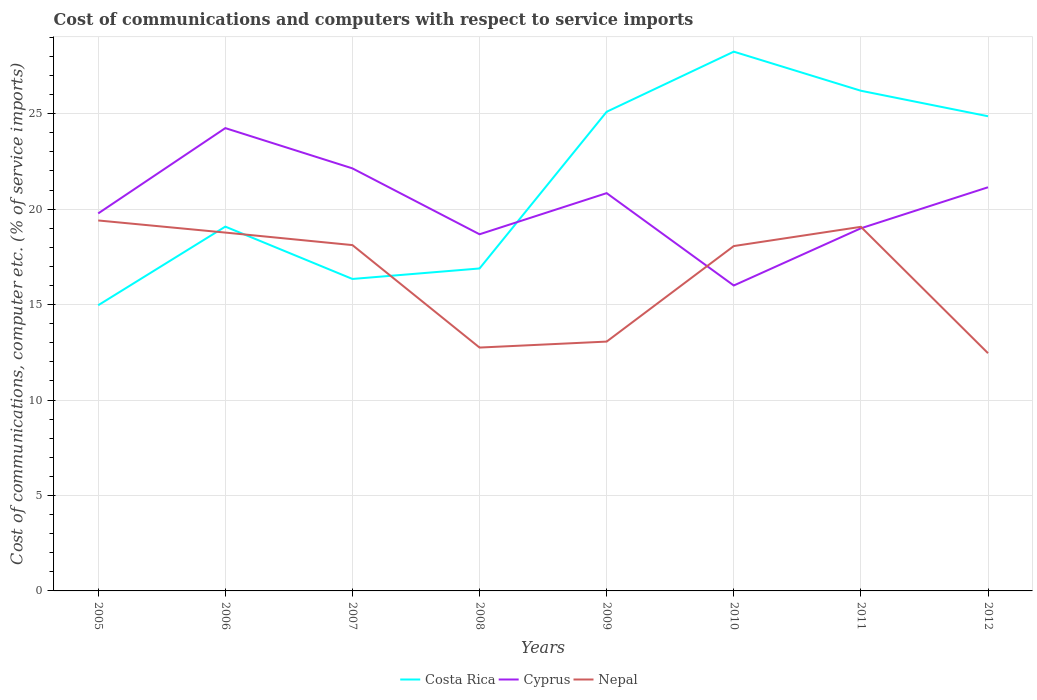Across all years, what is the maximum cost of communications and computers in Cyprus?
Offer a terse response. 16. In which year was the cost of communications and computers in Nepal maximum?
Make the answer very short. 2012. What is the total cost of communications and computers in Costa Rica in the graph?
Offer a terse response. 2.05. What is the difference between the highest and the second highest cost of communications and computers in Nepal?
Ensure brevity in your answer.  6.95. What is the difference between the highest and the lowest cost of communications and computers in Cyprus?
Your answer should be very brief. 4. Is the cost of communications and computers in Costa Rica strictly greater than the cost of communications and computers in Cyprus over the years?
Give a very brief answer. No. Are the values on the major ticks of Y-axis written in scientific E-notation?
Provide a short and direct response. No. Does the graph contain any zero values?
Your answer should be compact. No. Does the graph contain grids?
Make the answer very short. Yes. Where does the legend appear in the graph?
Offer a terse response. Bottom center. How many legend labels are there?
Keep it short and to the point. 3. How are the legend labels stacked?
Offer a very short reply. Horizontal. What is the title of the graph?
Offer a terse response. Cost of communications and computers with respect to service imports. What is the label or title of the Y-axis?
Provide a succinct answer. Cost of communications, computer etc. (% of service imports). What is the Cost of communications, computer etc. (% of service imports) of Costa Rica in 2005?
Give a very brief answer. 14.97. What is the Cost of communications, computer etc. (% of service imports) in Cyprus in 2005?
Your answer should be very brief. 19.78. What is the Cost of communications, computer etc. (% of service imports) in Nepal in 2005?
Provide a short and direct response. 19.41. What is the Cost of communications, computer etc. (% of service imports) of Costa Rica in 2006?
Your answer should be very brief. 19.09. What is the Cost of communications, computer etc. (% of service imports) in Cyprus in 2006?
Ensure brevity in your answer.  24.25. What is the Cost of communications, computer etc. (% of service imports) in Nepal in 2006?
Provide a short and direct response. 18.77. What is the Cost of communications, computer etc. (% of service imports) of Costa Rica in 2007?
Provide a short and direct response. 16.34. What is the Cost of communications, computer etc. (% of service imports) in Cyprus in 2007?
Your answer should be compact. 22.14. What is the Cost of communications, computer etc. (% of service imports) of Nepal in 2007?
Your response must be concise. 18.12. What is the Cost of communications, computer etc. (% of service imports) in Costa Rica in 2008?
Make the answer very short. 16.89. What is the Cost of communications, computer etc. (% of service imports) of Cyprus in 2008?
Offer a very short reply. 18.68. What is the Cost of communications, computer etc. (% of service imports) of Nepal in 2008?
Provide a short and direct response. 12.75. What is the Cost of communications, computer etc. (% of service imports) of Costa Rica in 2009?
Offer a terse response. 25.1. What is the Cost of communications, computer etc. (% of service imports) in Cyprus in 2009?
Provide a short and direct response. 20.84. What is the Cost of communications, computer etc. (% of service imports) of Nepal in 2009?
Provide a short and direct response. 13.06. What is the Cost of communications, computer etc. (% of service imports) in Costa Rica in 2010?
Offer a terse response. 28.25. What is the Cost of communications, computer etc. (% of service imports) in Cyprus in 2010?
Make the answer very short. 16. What is the Cost of communications, computer etc. (% of service imports) in Nepal in 2010?
Offer a very short reply. 18.07. What is the Cost of communications, computer etc. (% of service imports) of Costa Rica in 2011?
Keep it short and to the point. 26.2. What is the Cost of communications, computer etc. (% of service imports) of Cyprus in 2011?
Give a very brief answer. 19. What is the Cost of communications, computer etc. (% of service imports) of Nepal in 2011?
Your response must be concise. 19.07. What is the Cost of communications, computer etc. (% of service imports) of Costa Rica in 2012?
Your answer should be very brief. 24.87. What is the Cost of communications, computer etc. (% of service imports) of Cyprus in 2012?
Make the answer very short. 21.15. What is the Cost of communications, computer etc. (% of service imports) in Nepal in 2012?
Your answer should be very brief. 12.45. Across all years, what is the maximum Cost of communications, computer etc. (% of service imports) in Costa Rica?
Your response must be concise. 28.25. Across all years, what is the maximum Cost of communications, computer etc. (% of service imports) in Cyprus?
Provide a short and direct response. 24.25. Across all years, what is the maximum Cost of communications, computer etc. (% of service imports) in Nepal?
Keep it short and to the point. 19.41. Across all years, what is the minimum Cost of communications, computer etc. (% of service imports) of Costa Rica?
Keep it short and to the point. 14.97. Across all years, what is the minimum Cost of communications, computer etc. (% of service imports) in Cyprus?
Offer a very short reply. 16. Across all years, what is the minimum Cost of communications, computer etc. (% of service imports) in Nepal?
Ensure brevity in your answer.  12.45. What is the total Cost of communications, computer etc. (% of service imports) in Costa Rica in the graph?
Offer a very short reply. 171.71. What is the total Cost of communications, computer etc. (% of service imports) of Cyprus in the graph?
Give a very brief answer. 161.83. What is the total Cost of communications, computer etc. (% of service imports) of Nepal in the graph?
Provide a short and direct response. 131.7. What is the difference between the Cost of communications, computer etc. (% of service imports) in Costa Rica in 2005 and that in 2006?
Provide a short and direct response. -4.12. What is the difference between the Cost of communications, computer etc. (% of service imports) of Cyprus in 2005 and that in 2006?
Your answer should be compact. -4.47. What is the difference between the Cost of communications, computer etc. (% of service imports) in Nepal in 2005 and that in 2006?
Provide a succinct answer. 0.63. What is the difference between the Cost of communications, computer etc. (% of service imports) of Costa Rica in 2005 and that in 2007?
Provide a succinct answer. -1.38. What is the difference between the Cost of communications, computer etc. (% of service imports) of Cyprus in 2005 and that in 2007?
Offer a terse response. -2.36. What is the difference between the Cost of communications, computer etc. (% of service imports) in Nepal in 2005 and that in 2007?
Provide a short and direct response. 1.29. What is the difference between the Cost of communications, computer etc. (% of service imports) of Costa Rica in 2005 and that in 2008?
Provide a succinct answer. -1.93. What is the difference between the Cost of communications, computer etc. (% of service imports) of Cyprus in 2005 and that in 2008?
Provide a short and direct response. 1.09. What is the difference between the Cost of communications, computer etc. (% of service imports) of Nepal in 2005 and that in 2008?
Your answer should be compact. 6.66. What is the difference between the Cost of communications, computer etc. (% of service imports) of Costa Rica in 2005 and that in 2009?
Offer a terse response. -10.14. What is the difference between the Cost of communications, computer etc. (% of service imports) in Cyprus in 2005 and that in 2009?
Provide a short and direct response. -1.06. What is the difference between the Cost of communications, computer etc. (% of service imports) of Nepal in 2005 and that in 2009?
Make the answer very short. 6.35. What is the difference between the Cost of communications, computer etc. (% of service imports) of Costa Rica in 2005 and that in 2010?
Make the answer very short. -13.29. What is the difference between the Cost of communications, computer etc. (% of service imports) in Cyprus in 2005 and that in 2010?
Give a very brief answer. 3.78. What is the difference between the Cost of communications, computer etc. (% of service imports) of Nepal in 2005 and that in 2010?
Provide a succinct answer. 1.34. What is the difference between the Cost of communications, computer etc. (% of service imports) in Costa Rica in 2005 and that in 2011?
Offer a terse response. -11.24. What is the difference between the Cost of communications, computer etc. (% of service imports) in Cyprus in 2005 and that in 2011?
Offer a very short reply. 0.78. What is the difference between the Cost of communications, computer etc. (% of service imports) of Nepal in 2005 and that in 2011?
Your answer should be very brief. 0.33. What is the difference between the Cost of communications, computer etc. (% of service imports) in Costa Rica in 2005 and that in 2012?
Your answer should be very brief. -9.9. What is the difference between the Cost of communications, computer etc. (% of service imports) of Cyprus in 2005 and that in 2012?
Ensure brevity in your answer.  -1.37. What is the difference between the Cost of communications, computer etc. (% of service imports) in Nepal in 2005 and that in 2012?
Offer a terse response. 6.95. What is the difference between the Cost of communications, computer etc. (% of service imports) of Costa Rica in 2006 and that in 2007?
Your response must be concise. 2.74. What is the difference between the Cost of communications, computer etc. (% of service imports) of Cyprus in 2006 and that in 2007?
Keep it short and to the point. 2.11. What is the difference between the Cost of communications, computer etc. (% of service imports) in Nepal in 2006 and that in 2007?
Offer a terse response. 0.66. What is the difference between the Cost of communications, computer etc. (% of service imports) of Costa Rica in 2006 and that in 2008?
Make the answer very short. 2.19. What is the difference between the Cost of communications, computer etc. (% of service imports) of Cyprus in 2006 and that in 2008?
Provide a succinct answer. 5.56. What is the difference between the Cost of communications, computer etc. (% of service imports) of Nepal in 2006 and that in 2008?
Ensure brevity in your answer.  6.02. What is the difference between the Cost of communications, computer etc. (% of service imports) in Costa Rica in 2006 and that in 2009?
Offer a very short reply. -6.02. What is the difference between the Cost of communications, computer etc. (% of service imports) of Cyprus in 2006 and that in 2009?
Keep it short and to the point. 3.41. What is the difference between the Cost of communications, computer etc. (% of service imports) in Nepal in 2006 and that in 2009?
Ensure brevity in your answer.  5.71. What is the difference between the Cost of communications, computer etc. (% of service imports) in Costa Rica in 2006 and that in 2010?
Your answer should be very brief. -9.17. What is the difference between the Cost of communications, computer etc. (% of service imports) of Cyprus in 2006 and that in 2010?
Provide a short and direct response. 8.24. What is the difference between the Cost of communications, computer etc. (% of service imports) of Nepal in 2006 and that in 2010?
Your answer should be compact. 0.71. What is the difference between the Cost of communications, computer etc. (% of service imports) of Costa Rica in 2006 and that in 2011?
Provide a succinct answer. -7.12. What is the difference between the Cost of communications, computer etc. (% of service imports) in Cyprus in 2006 and that in 2011?
Make the answer very short. 5.25. What is the difference between the Cost of communications, computer etc. (% of service imports) of Nepal in 2006 and that in 2011?
Ensure brevity in your answer.  -0.3. What is the difference between the Cost of communications, computer etc. (% of service imports) in Costa Rica in 2006 and that in 2012?
Your response must be concise. -5.78. What is the difference between the Cost of communications, computer etc. (% of service imports) of Cyprus in 2006 and that in 2012?
Provide a succinct answer. 3.1. What is the difference between the Cost of communications, computer etc. (% of service imports) in Nepal in 2006 and that in 2012?
Offer a very short reply. 6.32. What is the difference between the Cost of communications, computer etc. (% of service imports) in Costa Rica in 2007 and that in 2008?
Your answer should be compact. -0.55. What is the difference between the Cost of communications, computer etc. (% of service imports) in Cyprus in 2007 and that in 2008?
Ensure brevity in your answer.  3.45. What is the difference between the Cost of communications, computer etc. (% of service imports) in Nepal in 2007 and that in 2008?
Provide a succinct answer. 5.37. What is the difference between the Cost of communications, computer etc. (% of service imports) of Costa Rica in 2007 and that in 2009?
Offer a terse response. -8.76. What is the difference between the Cost of communications, computer etc. (% of service imports) in Cyprus in 2007 and that in 2009?
Provide a short and direct response. 1.3. What is the difference between the Cost of communications, computer etc. (% of service imports) in Nepal in 2007 and that in 2009?
Ensure brevity in your answer.  5.05. What is the difference between the Cost of communications, computer etc. (% of service imports) of Costa Rica in 2007 and that in 2010?
Offer a very short reply. -11.91. What is the difference between the Cost of communications, computer etc. (% of service imports) in Cyprus in 2007 and that in 2010?
Your answer should be very brief. 6.14. What is the difference between the Cost of communications, computer etc. (% of service imports) in Nepal in 2007 and that in 2010?
Offer a very short reply. 0.05. What is the difference between the Cost of communications, computer etc. (% of service imports) of Costa Rica in 2007 and that in 2011?
Your answer should be compact. -9.86. What is the difference between the Cost of communications, computer etc. (% of service imports) in Cyprus in 2007 and that in 2011?
Offer a terse response. 3.14. What is the difference between the Cost of communications, computer etc. (% of service imports) of Nepal in 2007 and that in 2011?
Make the answer very short. -0.96. What is the difference between the Cost of communications, computer etc. (% of service imports) in Costa Rica in 2007 and that in 2012?
Your answer should be compact. -8.52. What is the difference between the Cost of communications, computer etc. (% of service imports) of Nepal in 2007 and that in 2012?
Provide a succinct answer. 5.66. What is the difference between the Cost of communications, computer etc. (% of service imports) of Costa Rica in 2008 and that in 2009?
Give a very brief answer. -8.21. What is the difference between the Cost of communications, computer etc. (% of service imports) in Cyprus in 2008 and that in 2009?
Your answer should be compact. -2.16. What is the difference between the Cost of communications, computer etc. (% of service imports) in Nepal in 2008 and that in 2009?
Your response must be concise. -0.31. What is the difference between the Cost of communications, computer etc. (% of service imports) of Costa Rica in 2008 and that in 2010?
Provide a succinct answer. -11.36. What is the difference between the Cost of communications, computer etc. (% of service imports) of Cyprus in 2008 and that in 2010?
Give a very brief answer. 2.68. What is the difference between the Cost of communications, computer etc. (% of service imports) in Nepal in 2008 and that in 2010?
Keep it short and to the point. -5.32. What is the difference between the Cost of communications, computer etc. (% of service imports) in Costa Rica in 2008 and that in 2011?
Ensure brevity in your answer.  -9.31. What is the difference between the Cost of communications, computer etc. (% of service imports) of Cyprus in 2008 and that in 2011?
Your answer should be compact. -0.31. What is the difference between the Cost of communications, computer etc. (% of service imports) in Nepal in 2008 and that in 2011?
Provide a succinct answer. -6.33. What is the difference between the Cost of communications, computer etc. (% of service imports) of Costa Rica in 2008 and that in 2012?
Make the answer very short. -7.97. What is the difference between the Cost of communications, computer etc. (% of service imports) in Cyprus in 2008 and that in 2012?
Your response must be concise. -2.46. What is the difference between the Cost of communications, computer etc. (% of service imports) of Nepal in 2008 and that in 2012?
Your answer should be very brief. 0.3. What is the difference between the Cost of communications, computer etc. (% of service imports) of Costa Rica in 2009 and that in 2010?
Keep it short and to the point. -3.15. What is the difference between the Cost of communications, computer etc. (% of service imports) of Cyprus in 2009 and that in 2010?
Make the answer very short. 4.84. What is the difference between the Cost of communications, computer etc. (% of service imports) of Nepal in 2009 and that in 2010?
Offer a very short reply. -5. What is the difference between the Cost of communications, computer etc. (% of service imports) in Costa Rica in 2009 and that in 2011?
Offer a terse response. -1.1. What is the difference between the Cost of communications, computer etc. (% of service imports) of Cyprus in 2009 and that in 2011?
Your answer should be very brief. 1.84. What is the difference between the Cost of communications, computer etc. (% of service imports) in Nepal in 2009 and that in 2011?
Your answer should be very brief. -6.01. What is the difference between the Cost of communications, computer etc. (% of service imports) in Costa Rica in 2009 and that in 2012?
Keep it short and to the point. 0.23. What is the difference between the Cost of communications, computer etc. (% of service imports) of Cyprus in 2009 and that in 2012?
Offer a terse response. -0.31. What is the difference between the Cost of communications, computer etc. (% of service imports) in Nepal in 2009 and that in 2012?
Make the answer very short. 0.61. What is the difference between the Cost of communications, computer etc. (% of service imports) in Costa Rica in 2010 and that in 2011?
Your answer should be compact. 2.05. What is the difference between the Cost of communications, computer etc. (% of service imports) of Cyprus in 2010 and that in 2011?
Make the answer very short. -3. What is the difference between the Cost of communications, computer etc. (% of service imports) of Nepal in 2010 and that in 2011?
Your response must be concise. -1.01. What is the difference between the Cost of communications, computer etc. (% of service imports) of Costa Rica in 2010 and that in 2012?
Make the answer very short. 3.38. What is the difference between the Cost of communications, computer etc. (% of service imports) in Cyprus in 2010 and that in 2012?
Give a very brief answer. -5.15. What is the difference between the Cost of communications, computer etc. (% of service imports) of Nepal in 2010 and that in 2012?
Provide a succinct answer. 5.61. What is the difference between the Cost of communications, computer etc. (% of service imports) of Costa Rica in 2011 and that in 2012?
Keep it short and to the point. 1.34. What is the difference between the Cost of communications, computer etc. (% of service imports) in Cyprus in 2011 and that in 2012?
Ensure brevity in your answer.  -2.15. What is the difference between the Cost of communications, computer etc. (% of service imports) of Nepal in 2011 and that in 2012?
Ensure brevity in your answer.  6.62. What is the difference between the Cost of communications, computer etc. (% of service imports) of Costa Rica in 2005 and the Cost of communications, computer etc. (% of service imports) of Cyprus in 2006?
Provide a short and direct response. -9.28. What is the difference between the Cost of communications, computer etc. (% of service imports) in Costa Rica in 2005 and the Cost of communications, computer etc. (% of service imports) in Nepal in 2006?
Make the answer very short. -3.81. What is the difference between the Cost of communications, computer etc. (% of service imports) of Cyprus in 2005 and the Cost of communications, computer etc. (% of service imports) of Nepal in 2006?
Offer a very short reply. 1. What is the difference between the Cost of communications, computer etc. (% of service imports) of Costa Rica in 2005 and the Cost of communications, computer etc. (% of service imports) of Cyprus in 2007?
Give a very brief answer. -7.17. What is the difference between the Cost of communications, computer etc. (% of service imports) in Costa Rica in 2005 and the Cost of communications, computer etc. (% of service imports) in Nepal in 2007?
Give a very brief answer. -3.15. What is the difference between the Cost of communications, computer etc. (% of service imports) in Cyprus in 2005 and the Cost of communications, computer etc. (% of service imports) in Nepal in 2007?
Keep it short and to the point. 1.66. What is the difference between the Cost of communications, computer etc. (% of service imports) of Costa Rica in 2005 and the Cost of communications, computer etc. (% of service imports) of Cyprus in 2008?
Your answer should be very brief. -3.72. What is the difference between the Cost of communications, computer etc. (% of service imports) in Costa Rica in 2005 and the Cost of communications, computer etc. (% of service imports) in Nepal in 2008?
Your response must be concise. 2.22. What is the difference between the Cost of communications, computer etc. (% of service imports) of Cyprus in 2005 and the Cost of communications, computer etc. (% of service imports) of Nepal in 2008?
Your answer should be compact. 7.03. What is the difference between the Cost of communications, computer etc. (% of service imports) of Costa Rica in 2005 and the Cost of communications, computer etc. (% of service imports) of Cyprus in 2009?
Your answer should be very brief. -5.87. What is the difference between the Cost of communications, computer etc. (% of service imports) in Costa Rica in 2005 and the Cost of communications, computer etc. (% of service imports) in Nepal in 2009?
Provide a short and direct response. 1.9. What is the difference between the Cost of communications, computer etc. (% of service imports) in Cyprus in 2005 and the Cost of communications, computer etc. (% of service imports) in Nepal in 2009?
Offer a very short reply. 6.71. What is the difference between the Cost of communications, computer etc. (% of service imports) of Costa Rica in 2005 and the Cost of communications, computer etc. (% of service imports) of Cyprus in 2010?
Provide a succinct answer. -1.03. What is the difference between the Cost of communications, computer etc. (% of service imports) of Costa Rica in 2005 and the Cost of communications, computer etc. (% of service imports) of Nepal in 2010?
Offer a terse response. -3.1. What is the difference between the Cost of communications, computer etc. (% of service imports) of Cyprus in 2005 and the Cost of communications, computer etc. (% of service imports) of Nepal in 2010?
Provide a succinct answer. 1.71. What is the difference between the Cost of communications, computer etc. (% of service imports) in Costa Rica in 2005 and the Cost of communications, computer etc. (% of service imports) in Cyprus in 2011?
Offer a very short reply. -4.03. What is the difference between the Cost of communications, computer etc. (% of service imports) in Costa Rica in 2005 and the Cost of communications, computer etc. (% of service imports) in Nepal in 2011?
Provide a short and direct response. -4.11. What is the difference between the Cost of communications, computer etc. (% of service imports) of Cyprus in 2005 and the Cost of communications, computer etc. (% of service imports) of Nepal in 2011?
Provide a succinct answer. 0.7. What is the difference between the Cost of communications, computer etc. (% of service imports) in Costa Rica in 2005 and the Cost of communications, computer etc. (% of service imports) in Cyprus in 2012?
Offer a very short reply. -6.18. What is the difference between the Cost of communications, computer etc. (% of service imports) in Costa Rica in 2005 and the Cost of communications, computer etc. (% of service imports) in Nepal in 2012?
Ensure brevity in your answer.  2.51. What is the difference between the Cost of communications, computer etc. (% of service imports) in Cyprus in 2005 and the Cost of communications, computer etc. (% of service imports) in Nepal in 2012?
Offer a terse response. 7.32. What is the difference between the Cost of communications, computer etc. (% of service imports) in Costa Rica in 2006 and the Cost of communications, computer etc. (% of service imports) in Cyprus in 2007?
Offer a very short reply. -3.05. What is the difference between the Cost of communications, computer etc. (% of service imports) in Cyprus in 2006 and the Cost of communications, computer etc. (% of service imports) in Nepal in 2007?
Ensure brevity in your answer.  6.13. What is the difference between the Cost of communications, computer etc. (% of service imports) of Costa Rica in 2006 and the Cost of communications, computer etc. (% of service imports) of Cyprus in 2008?
Your response must be concise. 0.4. What is the difference between the Cost of communications, computer etc. (% of service imports) in Costa Rica in 2006 and the Cost of communications, computer etc. (% of service imports) in Nepal in 2008?
Your response must be concise. 6.34. What is the difference between the Cost of communications, computer etc. (% of service imports) of Cyprus in 2006 and the Cost of communications, computer etc. (% of service imports) of Nepal in 2008?
Ensure brevity in your answer.  11.5. What is the difference between the Cost of communications, computer etc. (% of service imports) in Costa Rica in 2006 and the Cost of communications, computer etc. (% of service imports) in Cyprus in 2009?
Make the answer very short. -1.75. What is the difference between the Cost of communications, computer etc. (% of service imports) of Costa Rica in 2006 and the Cost of communications, computer etc. (% of service imports) of Nepal in 2009?
Your answer should be compact. 6.02. What is the difference between the Cost of communications, computer etc. (% of service imports) of Cyprus in 2006 and the Cost of communications, computer etc. (% of service imports) of Nepal in 2009?
Keep it short and to the point. 11.18. What is the difference between the Cost of communications, computer etc. (% of service imports) in Costa Rica in 2006 and the Cost of communications, computer etc. (% of service imports) in Cyprus in 2010?
Provide a succinct answer. 3.08. What is the difference between the Cost of communications, computer etc. (% of service imports) in Costa Rica in 2006 and the Cost of communications, computer etc. (% of service imports) in Nepal in 2010?
Your response must be concise. 1.02. What is the difference between the Cost of communications, computer etc. (% of service imports) in Cyprus in 2006 and the Cost of communications, computer etc. (% of service imports) in Nepal in 2010?
Give a very brief answer. 6.18. What is the difference between the Cost of communications, computer etc. (% of service imports) in Costa Rica in 2006 and the Cost of communications, computer etc. (% of service imports) in Cyprus in 2011?
Your response must be concise. 0.09. What is the difference between the Cost of communications, computer etc. (% of service imports) of Costa Rica in 2006 and the Cost of communications, computer etc. (% of service imports) of Nepal in 2011?
Give a very brief answer. 0.01. What is the difference between the Cost of communications, computer etc. (% of service imports) in Cyprus in 2006 and the Cost of communications, computer etc. (% of service imports) in Nepal in 2011?
Your answer should be very brief. 5.17. What is the difference between the Cost of communications, computer etc. (% of service imports) in Costa Rica in 2006 and the Cost of communications, computer etc. (% of service imports) in Cyprus in 2012?
Offer a very short reply. -2.06. What is the difference between the Cost of communications, computer etc. (% of service imports) in Costa Rica in 2006 and the Cost of communications, computer etc. (% of service imports) in Nepal in 2012?
Your response must be concise. 6.63. What is the difference between the Cost of communications, computer etc. (% of service imports) in Cyprus in 2006 and the Cost of communications, computer etc. (% of service imports) in Nepal in 2012?
Keep it short and to the point. 11.79. What is the difference between the Cost of communications, computer etc. (% of service imports) in Costa Rica in 2007 and the Cost of communications, computer etc. (% of service imports) in Cyprus in 2008?
Give a very brief answer. -2.34. What is the difference between the Cost of communications, computer etc. (% of service imports) in Costa Rica in 2007 and the Cost of communications, computer etc. (% of service imports) in Nepal in 2008?
Your answer should be very brief. 3.59. What is the difference between the Cost of communications, computer etc. (% of service imports) of Cyprus in 2007 and the Cost of communications, computer etc. (% of service imports) of Nepal in 2008?
Offer a terse response. 9.39. What is the difference between the Cost of communications, computer etc. (% of service imports) of Costa Rica in 2007 and the Cost of communications, computer etc. (% of service imports) of Cyprus in 2009?
Give a very brief answer. -4.5. What is the difference between the Cost of communications, computer etc. (% of service imports) in Costa Rica in 2007 and the Cost of communications, computer etc. (% of service imports) in Nepal in 2009?
Provide a short and direct response. 3.28. What is the difference between the Cost of communications, computer etc. (% of service imports) of Cyprus in 2007 and the Cost of communications, computer etc. (% of service imports) of Nepal in 2009?
Your answer should be very brief. 9.07. What is the difference between the Cost of communications, computer etc. (% of service imports) in Costa Rica in 2007 and the Cost of communications, computer etc. (% of service imports) in Cyprus in 2010?
Give a very brief answer. 0.34. What is the difference between the Cost of communications, computer etc. (% of service imports) in Costa Rica in 2007 and the Cost of communications, computer etc. (% of service imports) in Nepal in 2010?
Offer a terse response. -1.72. What is the difference between the Cost of communications, computer etc. (% of service imports) of Cyprus in 2007 and the Cost of communications, computer etc. (% of service imports) of Nepal in 2010?
Make the answer very short. 4.07. What is the difference between the Cost of communications, computer etc. (% of service imports) in Costa Rica in 2007 and the Cost of communications, computer etc. (% of service imports) in Cyprus in 2011?
Provide a succinct answer. -2.65. What is the difference between the Cost of communications, computer etc. (% of service imports) in Costa Rica in 2007 and the Cost of communications, computer etc. (% of service imports) in Nepal in 2011?
Provide a short and direct response. -2.73. What is the difference between the Cost of communications, computer etc. (% of service imports) in Cyprus in 2007 and the Cost of communications, computer etc. (% of service imports) in Nepal in 2011?
Your answer should be compact. 3.06. What is the difference between the Cost of communications, computer etc. (% of service imports) of Costa Rica in 2007 and the Cost of communications, computer etc. (% of service imports) of Cyprus in 2012?
Offer a very short reply. -4.8. What is the difference between the Cost of communications, computer etc. (% of service imports) of Costa Rica in 2007 and the Cost of communications, computer etc. (% of service imports) of Nepal in 2012?
Your answer should be compact. 3.89. What is the difference between the Cost of communications, computer etc. (% of service imports) of Cyprus in 2007 and the Cost of communications, computer etc. (% of service imports) of Nepal in 2012?
Provide a succinct answer. 9.68. What is the difference between the Cost of communications, computer etc. (% of service imports) of Costa Rica in 2008 and the Cost of communications, computer etc. (% of service imports) of Cyprus in 2009?
Provide a succinct answer. -3.95. What is the difference between the Cost of communications, computer etc. (% of service imports) of Costa Rica in 2008 and the Cost of communications, computer etc. (% of service imports) of Nepal in 2009?
Give a very brief answer. 3.83. What is the difference between the Cost of communications, computer etc. (% of service imports) of Cyprus in 2008 and the Cost of communications, computer etc. (% of service imports) of Nepal in 2009?
Give a very brief answer. 5.62. What is the difference between the Cost of communications, computer etc. (% of service imports) in Costa Rica in 2008 and the Cost of communications, computer etc. (% of service imports) in Cyprus in 2010?
Ensure brevity in your answer.  0.89. What is the difference between the Cost of communications, computer etc. (% of service imports) of Costa Rica in 2008 and the Cost of communications, computer etc. (% of service imports) of Nepal in 2010?
Provide a short and direct response. -1.17. What is the difference between the Cost of communications, computer etc. (% of service imports) of Cyprus in 2008 and the Cost of communications, computer etc. (% of service imports) of Nepal in 2010?
Give a very brief answer. 0.62. What is the difference between the Cost of communications, computer etc. (% of service imports) in Costa Rica in 2008 and the Cost of communications, computer etc. (% of service imports) in Cyprus in 2011?
Your answer should be very brief. -2.1. What is the difference between the Cost of communications, computer etc. (% of service imports) in Costa Rica in 2008 and the Cost of communications, computer etc. (% of service imports) in Nepal in 2011?
Provide a succinct answer. -2.18. What is the difference between the Cost of communications, computer etc. (% of service imports) of Cyprus in 2008 and the Cost of communications, computer etc. (% of service imports) of Nepal in 2011?
Ensure brevity in your answer.  -0.39. What is the difference between the Cost of communications, computer etc. (% of service imports) of Costa Rica in 2008 and the Cost of communications, computer etc. (% of service imports) of Cyprus in 2012?
Offer a terse response. -4.25. What is the difference between the Cost of communications, computer etc. (% of service imports) of Costa Rica in 2008 and the Cost of communications, computer etc. (% of service imports) of Nepal in 2012?
Your response must be concise. 4.44. What is the difference between the Cost of communications, computer etc. (% of service imports) in Cyprus in 2008 and the Cost of communications, computer etc. (% of service imports) in Nepal in 2012?
Make the answer very short. 6.23. What is the difference between the Cost of communications, computer etc. (% of service imports) of Costa Rica in 2009 and the Cost of communications, computer etc. (% of service imports) of Cyprus in 2010?
Provide a short and direct response. 9.1. What is the difference between the Cost of communications, computer etc. (% of service imports) in Costa Rica in 2009 and the Cost of communications, computer etc. (% of service imports) in Nepal in 2010?
Your answer should be compact. 7.04. What is the difference between the Cost of communications, computer etc. (% of service imports) in Cyprus in 2009 and the Cost of communications, computer etc. (% of service imports) in Nepal in 2010?
Offer a very short reply. 2.77. What is the difference between the Cost of communications, computer etc. (% of service imports) in Costa Rica in 2009 and the Cost of communications, computer etc. (% of service imports) in Cyprus in 2011?
Keep it short and to the point. 6.1. What is the difference between the Cost of communications, computer etc. (% of service imports) in Costa Rica in 2009 and the Cost of communications, computer etc. (% of service imports) in Nepal in 2011?
Make the answer very short. 6.03. What is the difference between the Cost of communications, computer etc. (% of service imports) in Cyprus in 2009 and the Cost of communications, computer etc. (% of service imports) in Nepal in 2011?
Give a very brief answer. 1.77. What is the difference between the Cost of communications, computer etc. (% of service imports) in Costa Rica in 2009 and the Cost of communications, computer etc. (% of service imports) in Cyprus in 2012?
Provide a short and direct response. 3.96. What is the difference between the Cost of communications, computer etc. (% of service imports) of Costa Rica in 2009 and the Cost of communications, computer etc. (% of service imports) of Nepal in 2012?
Your answer should be very brief. 12.65. What is the difference between the Cost of communications, computer etc. (% of service imports) in Cyprus in 2009 and the Cost of communications, computer etc. (% of service imports) in Nepal in 2012?
Offer a very short reply. 8.39. What is the difference between the Cost of communications, computer etc. (% of service imports) in Costa Rica in 2010 and the Cost of communications, computer etc. (% of service imports) in Cyprus in 2011?
Provide a short and direct response. 9.25. What is the difference between the Cost of communications, computer etc. (% of service imports) of Costa Rica in 2010 and the Cost of communications, computer etc. (% of service imports) of Nepal in 2011?
Offer a very short reply. 9.18. What is the difference between the Cost of communications, computer etc. (% of service imports) in Cyprus in 2010 and the Cost of communications, computer etc. (% of service imports) in Nepal in 2011?
Keep it short and to the point. -3.07. What is the difference between the Cost of communications, computer etc. (% of service imports) of Costa Rica in 2010 and the Cost of communications, computer etc. (% of service imports) of Cyprus in 2012?
Ensure brevity in your answer.  7.1. What is the difference between the Cost of communications, computer etc. (% of service imports) of Costa Rica in 2010 and the Cost of communications, computer etc. (% of service imports) of Nepal in 2012?
Make the answer very short. 15.8. What is the difference between the Cost of communications, computer etc. (% of service imports) of Cyprus in 2010 and the Cost of communications, computer etc. (% of service imports) of Nepal in 2012?
Offer a very short reply. 3.55. What is the difference between the Cost of communications, computer etc. (% of service imports) of Costa Rica in 2011 and the Cost of communications, computer etc. (% of service imports) of Cyprus in 2012?
Your answer should be compact. 5.06. What is the difference between the Cost of communications, computer etc. (% of service imports) in Costa Rica in 2011 and the Cost of communications, computer etc. (% of service imports) in Nepal in 2012?
Offer a very short reply. 13.75. What is the difference between the Cost of communications, computer etc. (% of service imports) of Cyprus in 2011 and the Cost of communications, computer etc. (% of service imports) of Nepal in 2012?
Provide a short and direct response. 6.54. What is the average Cost of communications, computer etc. (% of service imports) in Costa Rica per year?
Ensure brevity in your answer.  21.46. What is the average Cost of communications, computer etc. (% of service imports) of Cyprus per year?
Your answer should be very brief. 20.23. What is the average Cost of communications, computer etc. (% of service imports) of Nepal per year?
Keep it short and to the point. 16.46. In the year 2005, what is the difference between the Cost of communications, computer etc. (% of service imports) of Costa Rica and Cost of communications, computer etc. (% of service imports) of Cyprus?
Make the answer very short. -4.81. In the year 2005, what is the difference between the Cost of communications, computer etc. (% of service imports) of Costa Rica and Cost of communications, computer etc. (% of service imports) of Nepal?
Provide a short and direct response. -4.44. In the year 2005, what is the difference between the Cost of communications, computer etc. (% of service imports) in Cyprus and Cost of communications, computer etc. (% of service imports) in Nepal?
Provide a succinct answer. 0.37. In the year 2006, what is the difference between the Cost of communications, computer etc. (% of service imports) in Costa Rica and Cost of communications, computer etc. (% of service imports) in Cyprus?
Your answer should be compact. -5.16. In the year 2006, what is the difference between the Cost of communications, computer etc. (% of service imports) of Costa Rica and Cost of communications, computer etc. (% of service imports) of Nepal?
Your answer should be very brief. 0.31. In the year 2006, what is the difference between the Cost of communications, computer etc. (% of service imports) in Cyprus and Cost of communications, computer etc. (% of service imports) in Nepal?
Your answer should be very brief. 5.47. In the year 2007, what is the difference between the Cost of communications, computer etc. (% of service imports) of Costa Rica and Cost of communications, computer etc. (% of service imports) of Cyprus?
Offer a terse response. -5.79. In the year 2007, what is the difference between the Cost of communications, computer etc. (% of service imports) in Costa Rica and Cost of communications, computer etc. (% of service imports) in Nepal?
Make the answer very short. -1.77. In the year 2007, what is the difference between the Cost of communications, computer etc. (% of service imports) of Cyprus and Cost of communications, computer etc. (% of service imports) of Nepal?
Ensure brevity in your answer.  4.02. In the year 2008, what is the difference between the Cost of communications, computer etc. (% of service imports) of Costa Rica and Cost of communications, computer etc. (% of service imports) of Cyprus?
Give a very brief answer. -1.79. In the year 2008, what is the difference between the Cost of communications, computer etc. (% of service imports) of Costa Rica and Cost of communications, computer etc. (% of service imports) of Nepal?
Offer a very short reply. 4.14. In the year 2008, what is the difference between the Cost of communications, computer etc. (% of service imports) of Cyprus and Cost of communications, computer etc. (% of service imports) of Nepal?
Give a very brief answer. 5.93. In the year 2009, what is the difference between the Cost of communications, computer etc. (% of service imports) in Costa Rica and Cost of communications, computer etc. (% of service imports) in Cyprus?
Keep it short and to the point. 4.26. In the year 2009, what is the difference between the Cost of communications, computer etc. (% of service imports) in Costa Rica and Cost of communications, computer etc. (% of service imports) in Nepal?
Your answer should be compact. 12.04. In the year 2009, what is the difference between the Cost of communications, computer etc. (% of service imports) in Cyprus and Cost of communications, computer etc. (% of service imports) in Nepal?
Your answer should be very brief. 7.78. In the year 2010, what is the difference between the Cost of communications, computer etc. (% of service imports) in Costa Rica and Cost of communications, computer etc. (% of service imports) in Cyprus?
Offer a terse response. 12.25. In the year 2010, what is the difference between the Cost of communications, computer etc. (% of service imports) in Costa Rica and Cost of communications, computer etc. (% of service imports) in Nepal?
Ensure brevity in your answer.  10.18. In the year 2010, what is the difference between the Cost of communications, computer etc. (% of service imports) of Cyprus and Cost of communications, computer etc. (% of service imports) of Nepal?
Make the answer very short. -2.07. In the year 2011, what is the difference between the Cost of communications, computer etc. (% of service imports) in Costa Rica and Cost of communications, computer etc. (% of service imports) in Cyprus?
Offer a very short reply. 7.21. In the year 2011, what is the difference between the Cost of communications, computer etc. (% of service imports) of Costa Rica and Cost of communications, computer etc. (% of service imports) of Nepal?
Offer a terse response. 7.13. In the year 2011, what is the difference between the Cost of communications, computer etc. (% of service imports) in Cyprus and Cost of communications, computer etc. (% of service imports) in Nepal?
Your answer should be very brief. -0.08. In the year 2012, what is the difference between the Cost of communications, computer etc. (% of service imports) in Costa Rica and Cost of communications, computer etc. (% of service imports) in Cyprus?
Provide a short and direct response. 3.72. In the year 2012, what is the difference between the Cost of communications, computer etc. (% of service imports) in Costa Rica and Cost of communications, computer etc. (% of service imports) in Nepal?
Your answer should be very brief. 12.41. In the year 2012, what is the difference between the Cost of communications, computer etc. (% of service imports) in Cyprus and Cost of communications, computer etc. (% of service imports) in Nepal?
Ensure brevity in your answer.  8.69. What is the ratio of the Cost of communications, computer etc. (% of service imports) in Costa Rica in 2005 to that in 2006?
Provide a succinct answer. 0.78. What is the ratio of the Cost of communications, computer etc. (% of service imports) in Cyprus in 2005 to that in 2006?
Make the answer very short. 0.82. What is the ratio of the Cost of communications, computer etc. (% of service imports) of Nepal in 2005 to that in 2006?
Offer a terse response. 1.03. What is the ratio of the Cost of communications, computer etc. (% of service imports) in Costa Rica in 2005 to that in 2007?
Keep it short and to the point. 0.92. What is the ratio of the Cost of communications, computer etc. (% of service imports) in Cyprus in 2005 to that in 2007?
Your response must be concise. 0.89. What is the ratio of the Cost of communications, computer etc. (% of service imports) in Nepal in 2005 to that in 2007?
Provide a short and direct response. 1.07. What is the ratio of the Cost of communications, computer etc. (% of service imports) of Costa Rica in 2005 to that in 2008?
Offer a very short reply. 0.89. What is the ratio of the Cost of communications, computer etc. (% of service imports) in Cyprus in 2005 to that in 2008?
Provide a succinct answer. 1.06. What is the ratio of the Cost of communications, computer etc. (% of service imports) of Nepal in 2005 to that in 2008?
Your answer should be compact. 1.52. What is the ratio of the Cost of communications, computer etc. (% of service imports) in Costa Rica in 2005 to that in 2009?
Your response must be concise. 0.6. What is the ratio of the Cost of communications, computer etc. (% of service imports) of Cyprus in 2005 to that in 2009?
Ensure brevity in your answer.  0.95. What is the ratio of the Cost of communications, computer etc. (% of service imports) in Nepal in 2005 to that in 2009?
Ensure brevity in your answer.  1.49. What is the ratio of the Cost of communications, computer etc. (% of service imports) in Costa Rica in 2005 to that in 2010?
Offer a terse response. 0.53. What is the ratio of the Cost of communications, computer etc. (% of service imports) in Cyprus in 2005 to that in 2010?
Your answer should be compact. 1.24. What is the ratio of the Cost of communications, computer etc. (% of service imports) in Nepal in 2005 to that in 2010?
Provide a succinct answer. 1.07. What is the ratio of the Cost of communications, computer etc. (% of service imports) in Costa Rica in 2005 to that in 2011?
Make the answer very short. 0.57. What is the ratio of the Cost of communications, computer etc. (% of service imports) of Cyprus in 2005 to that in 2011?
Keep it short and to the point. 1.04. What is the ratio of the Cost of communications, computer etc. (% of service imports) in Nepal in 2005 to that in 2011?
Offer a very short reply. 1.02. What is the ratio of the Cost of communications, computer etc. (% of service imports) in Costa Rica in 2005 to that in 2012?
Ensure brevity in your answer.  0.6. What is the ratio of the Cost of communications, computer etc. (% of service imports) in Cyprus in 2005 to that in 2012?
Offer a very short reply. 0.94. What is the ratio of the Cost of communications, computer etc. (% of service imports) in Nepal in 2005 to that in 2012?
Offer a terse response. 1.56. What is the ratio of the Cost of communications, computer etc. (% of service imports) of Costa Rica in 2006 to that in 2007?
Offer a very short reply. 1.17. What is the ratio of the Cost of communications, computer etc. (% of service imports) of Cyprus in 2006 to that in 2007?
Keep it short and to the point. 1.1. What is the ratio of the Cost of communications, computer etc. (% of service imports) of Nepal in 2006 to that in 2007?
Make the answer very short. 1.04. What is the ratio of the Cost of communications, computer etc. (% of service imports) in Costa Rica in 2006 to that in 2008?
Your answer should be very brief. 1.13. What is the ratio of the Cost of communications, computer etc. (% of service imports) in Cyprus in 2006 to that in 2008?
Provide a succinct answer. 1.3. What is the ratio of the Cost of communications, computer etc. (% of service imports) in Nepal in 2006 to that in 2008?
Keep it short and to the point. 1.47. What is the ratio of the Cost of communications, computer etc. (% of service imports) in Costa Rica in 2006 to that in 2009?
Make the answer very short. 0.76. What is the ratio of the Cost of communications, computer etc. (% of service imports) of Cyprus in 2006 to that in 2009?
Ensure brevity in your answer.  1.16. What is the ratio of the Cost of communications, computer etc. (% of service imports) of Nepal in 2006 to that in 2009?
Offer a terse response. 1.44. What is the ratio of the Cost of communications, computer etc. (% of service imports) of Costa Rica in 2006 to that in 2010?
Offer a very short reply. 0.68. What is the ratio of the Cost of communications, computer etc. (% of service imports) in Cyprus in 2006 to that in 2010?
Your answer should be compact. 1.52. What is the ratio of the Cost of communications, computer etc. (% of service imports) in Nepal in 2006 to that in 2010?
Offer a terse response. 1.04. What is the ratio of the Cost of communications, computer etc. (% of service imports) of Costa Rica in 2006 to that in 2011?
Keep it short and to the point. 0.73. What is the ratio of the Cost of communications, computer etc. (% of service imports) in Cyprus in 2006 to that in 2011?
Keep it short and to the point. 1.28. What is the ratio of the Cost of communications, computer etc. (% of service imports) of Nepal in 2006 to that in 2011?
Provide a succinct answer. 0.98. What is the ratio of the Cost of communications, computer etc. (% of service imports) of Costa Rica in 2006 to that in 2012?
Keep it short and to the point. 0.77. What is the ratio of the Cost of communications, computer etc. (% of service imports) in Cyprus in 2006 to that in 2012?
Offer a terse response. 1.15. What is the ratio of the Cost of communications, computer etc. (% of service imports) in Nepal in 2006 to that in 2012?
Offer a terse response. 1.51. What is the ratio of the Cost of communications, computer etc. (% of service imports) in Costa Rica in 2007 to that in 2008?
Offer a terse response. 0.97. What is the ratio of the Cost of communications, computer etc. (% of service imports) of Cyprus in 2007 to that in 2008?
Ensure brevity in your answer.  1.18. What is the ratio of the Cost of communications, computer etc. (% of service imports) in Nepal in 2007 to that in 2008?
Provide a succinct answer. 1.42. What is the ratio of the Cost of communications, computer etc. (% of service imports) in Costa Rica in 2007 to that in 2009?
Make the answer very short. 0.65. What is the ratio of the Cost of communications, computer etc. (% of service imports) in Cyprus in 2007 to that in 2009?
Offer a terse response. 1.06. What is the ratio of the Cost of communications, computer etc. (% of service imports) of Nepal in 2007 to that in 2009?
Provide a succinct answer. 1.39. What is the ratio of the Cost of communications, computer etc. (% of service imports) in Costa Rica in 2007 to that in 2010?
Make the answer very short. 0.58. What is the ratio of the Cost of communications, computer etc. (% of service imports) in Cyprus in 2007 to that in 2010?
Your response must be concise. 1.38. What is the ratio of the Cost of communications, computer etc. (% of service imports) in Costa Rica in 2007 to that in 2011?
Offer a very short reply. 0.62. What is the ratio of the Cost of communications, computer etc. (% of service imports) in Cyprus in 2007 to that in 2011?
Offer a terse response. 1.17. What is the ratio of the Cost of communications, computer etc. (% of service imports) in Nepal in 2007 to that in 2011?
Your response must be concise. 0.95. What is the ratio of the Cost of communications, computer etc. (% of service imports) in Costa Rica in 2007 to that in 2012?
Provide a short and direct response. 0.66. What is the ratio of the Cost of communications, computer etc. (% of service imports) of Cyprus in 2007 to that in 2012?
Offer a very short reply. 1.05. What is the ratio of the Cost of communications, computer etc. (% of service imports) in Nepal in 2007 to that in 2012?
Make the answer very short. 1.45. What is the ratio of the Cost of communications, computer etc. (% of service imports) in Costa Rica in 2008 to that in 2009?
Give a very brief answer. 0.67. What is the ratio of the Cost of communications, computer etc. (% of service imports) of Cyprus in 2008 to that in 2009?
Offer a very short reply. 0.9. What is the ratio of the Cost of communications, computer etc. (% of service imports) in Costa Rica in 2008 to that in 2010?
Your answer should be very brief. 0.6. What is the ratio of the Cost of communications, computer etc. (% of service imports) of Cyprus in 2008 to that in 2010?
Offer a very short reply. 1.17. What is the ratio of the Cost of communications, computer etc. (% of service imports) of Nepal in 2008 to that in 2010?
Your answer should be compact. 0.71. What is the ratio of the Cost of communications, computer etc. (% of service imports) in Costa Rica in 2008 to that in 2011?
Give a very brief answer. 0.64. What is the ratio of the Cost of communications, computer etc. (% of service imports) of Cyprus in 2008 to that in 2011?
Keep it short and to the point. 0.98. What is the ratio of the Cost of communications, computer etc. (% of service imports) of Nepal in 2008 to that in 2011?
Your answer should be compact. 0.67. What is the ratio of the Cost of communications, computer etc. (% of service imports) in Costa Rica in 2008 to that in 2012?
Keep it short and to the point. 0.68. What is the ratio of the Cost of communications, computer etc. (% of service imports) of Cyprus in 2008 to that in 2012?
Offer a terse response. 0.88. What is the ratio of the Cost of communications, computer etc. (% of service imports) of Nepal in 2008 to that in 2012?
Make the answer very short. 1.02. What is the ratio of the Cost of communications, computer etc. (% of service imports) in Costa Rica in 2009 to that in 2010?
Your answer should be very brief. 0.89. What is the ratio of the Cost of communications, computer etc. (% of service imports) of Cyprus in 2009 to that in 2010?
Ensure brevity in your answer.  1.3. What is the ratio of the Cost of communications, computer etc. (% of service imports) of Nepal in 2009 to that in 2010?
Your response must be concise. 0.72. What is the ratio of the Cost of communications, computer etc. (% of service imports) in Costa Rica in 2009 to that in 2011?
Offer a terse response. 0.96. What is the ratio of the Cost of communications, computer etc. (% of service imports) in Cyprus in 2009 to that in 2011?
Make the answer very short. 1.1. What is the ratio of the Cost of communications, computer etc. (% of service imports) in Nepal in 2009 to that in 2011?
Keep it short and to the point. 0.68. What is the ratio of the Cost of communications, computer etc. (% of service imports) in Costa Rica in 2009 to that in 2012?
Make the answer very short. 1.01. What is the ratio of the Cost of communications, computer etc. (% of service imports) of Cyprus in 2009 to that in 2012?
Your answer should be compact. 0.99. What is the ratio of the Cost of communications, computer etc. (% of service imports) in Nepal in 2009 to that in 2012?
Make the answer very short. 1.05. What is the ratio of the Cost of communications, computer etc. (% of service imports) of Costa Rica in 2010 to that in 2011?
Give a very brief answer. 1.08. What is the ratio of the Cost of communications, computer etc. (% of service imports) in Cyprus in 2010 to that in 2011?
Provide a short and direct response. 0.84. What is the ratio of the Cost of communications, computer etc. (% of service imports) of Nepal in 2010 to that in 2011?
Your answer should be compact. 0.95. What is the ratio of the Cost of communications, computer etc. (% of service imports) of Costa Rica in 2010 to that in 2012?
Offer a very short reply. 1.14. What is the ratio of the Cost of communications, computer etc. (% of service imports) of Cyprus in 2010 to that in 2012?
Ensure brevity in your answer.  0.76. What is the ratio of the Cost of communications, computer etc. (% of service imports) in Nepal in 2010 to that in 2012?
Give a very brief answer. 1.45. What is the ratio of the Cost of communications, computer etc. (% of service imports) of Costa Rica in 2011 to that in 2012?
Your answer should be very brief. 1.05. What is the ratio of the Cost of communications, computer etc. (% of service imports) in Cyprus in 2011 to that in 2012?
Offer a very short reply. 0.9. What is the ratio of the Cost of communications, computer etc. (% of service imports) of Nepal in 2011 to that in 2012?
Your answer should be very brief. 1.53. What is the difference between the highest and the second highest Cost of communications, computer etc. (% of service imports) in Costa Rica?
Your response must be concise. 2.05. What is the difference between the highest and the second highest Cost of communications, computer etc. (% of service imports) in Cyprus?
Keep it short and to the point. 2.11. What is the difference between the highest and the second highest Cost of communications, computer etc. (% of service imports) of Nepal?
Give a very brief answer. 0.33. What is the difference between the highest and the lowest Cost of communications, computer etc. (% of service imports) of Costa Rica?
Your answer should be compact. 13.29. What is the difference between the highest and the lowest Cost of communications, computer etc. (% of service imports) of Cyprus?
Keep it short and to the point. 8.24. What is the difference between the highest and the lowest Cost of communications, computer etc. (% of service imports) of Nepal?
Ensure brevity in your answer.  6.95. 